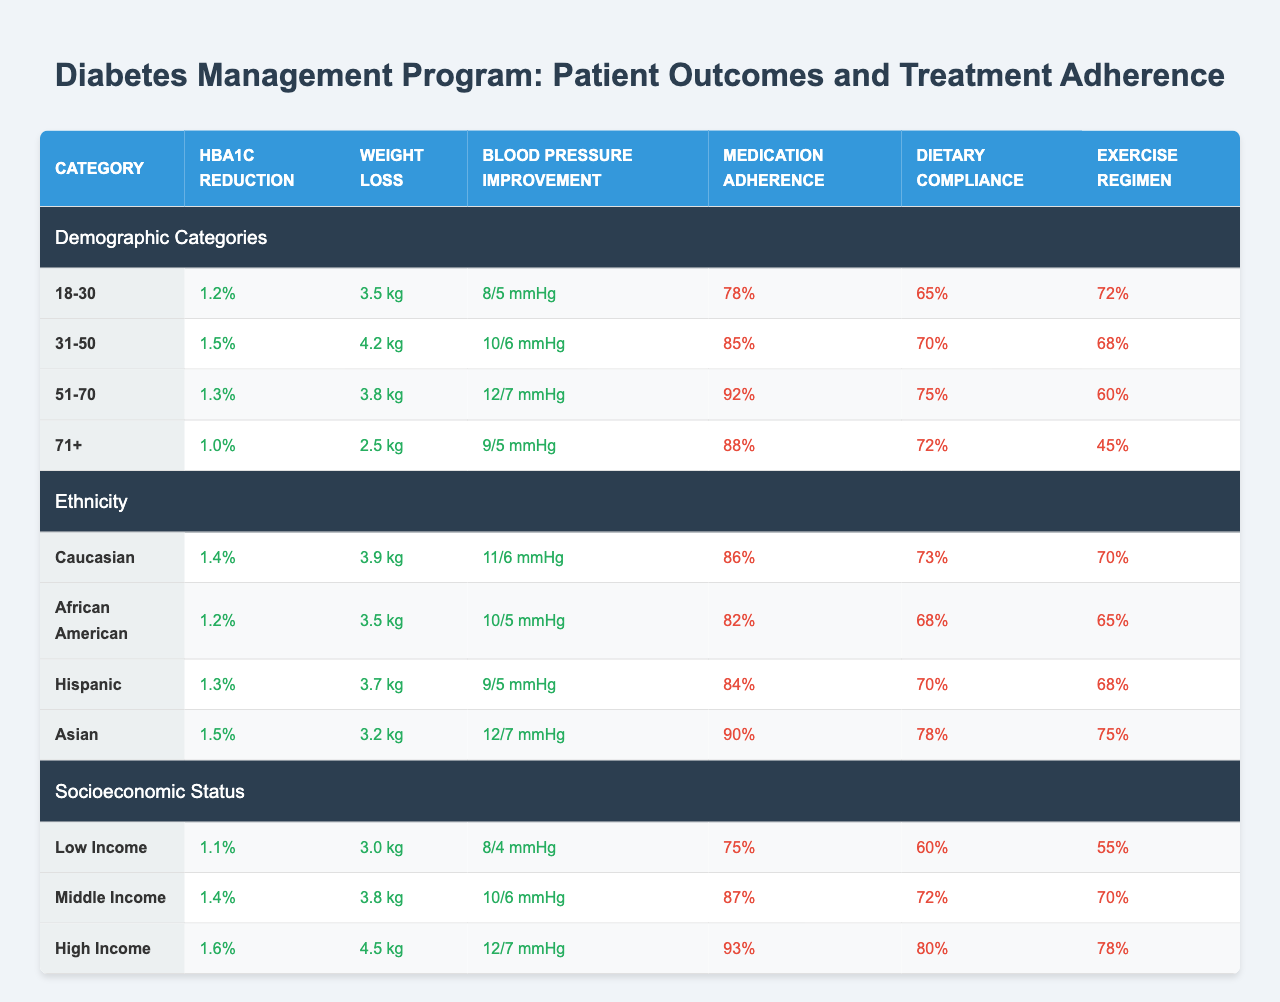What is the HbA1c reduction for the 31-50 age group? The table shows that the HbA1c reduction for the 31-50 age group is listed directly in the patient outcomes section.
Answer: 1.5% Which age group had the highest medication adherence rate? By comparing the medication adherence rates across all age groups, the 51-70 age group has the highest rate at 92%.
Answer: 51-70 What is the average weight loss for middle income patients? The table indicates that the weight loss for middle income patients is 3.8 kg. Since there is only one value provided for this income level, the average is 3.8 kg.
Answer: 3.8 kg Is the blood pressure improvement for Hispanic patients greater than that for African American patients? Comparing the blood pressure improvements shown in the table, Hispanic patients show an improvement of 9/5 mmHg, while African American patients show 10/5 mmHg. Since 10/5 mmHg is greater than 9/5 mmHg, the statement is true.
Answer: Yes What is the difference in HbA1c reduction between the low income and high income groups? The HbA1c reduction for low income is 1.1% and for high income is 1.6%. The difference is calculated as 1.6% - 1.1% = 0.5%.
Answer: 0.5% Which demographic group has the highest dietary compliance rate? By evaluating the dietary compliance rates across all demographic categories, high income patients achieve the highest rate of 80%.
Answer: High Income What is the total improvement in blood pressure for the 71+ age group? The improvement for the 71+ age group is 9/5 mmHg, which denotes the systolic and diastolic blood pressure changes. This value is listed directly in the patient outcomes section.
Answer: 9/5 mmHg How does the exercise regimen adherence for the 51-70 age group compare to the 71+ age group? The exercise regimen adherence for the 51-70 age group is 60%, whereas for the 71+ age group it is 45%. Hence, 60% is greater than 45%, indicating the 51-70 age group has a higher rate.
Answer: 51-70 has higher adherence What is the median weight loss across all income levels? Weight loss values for each income level are 3.0 kg (Low), 3.8 kg (Middle), and 4.5 kg (High). The median is the middle value when arranged in order, which is 3.8 kg.
Answer: 3.8 kg Which ethnic group had the lowest blood pressure improvement? By reviewing the table, the African American group shows a blood pressure improvement of 10/5 mmHg, which is lower than the other groups' improvements.
Answer: African American 